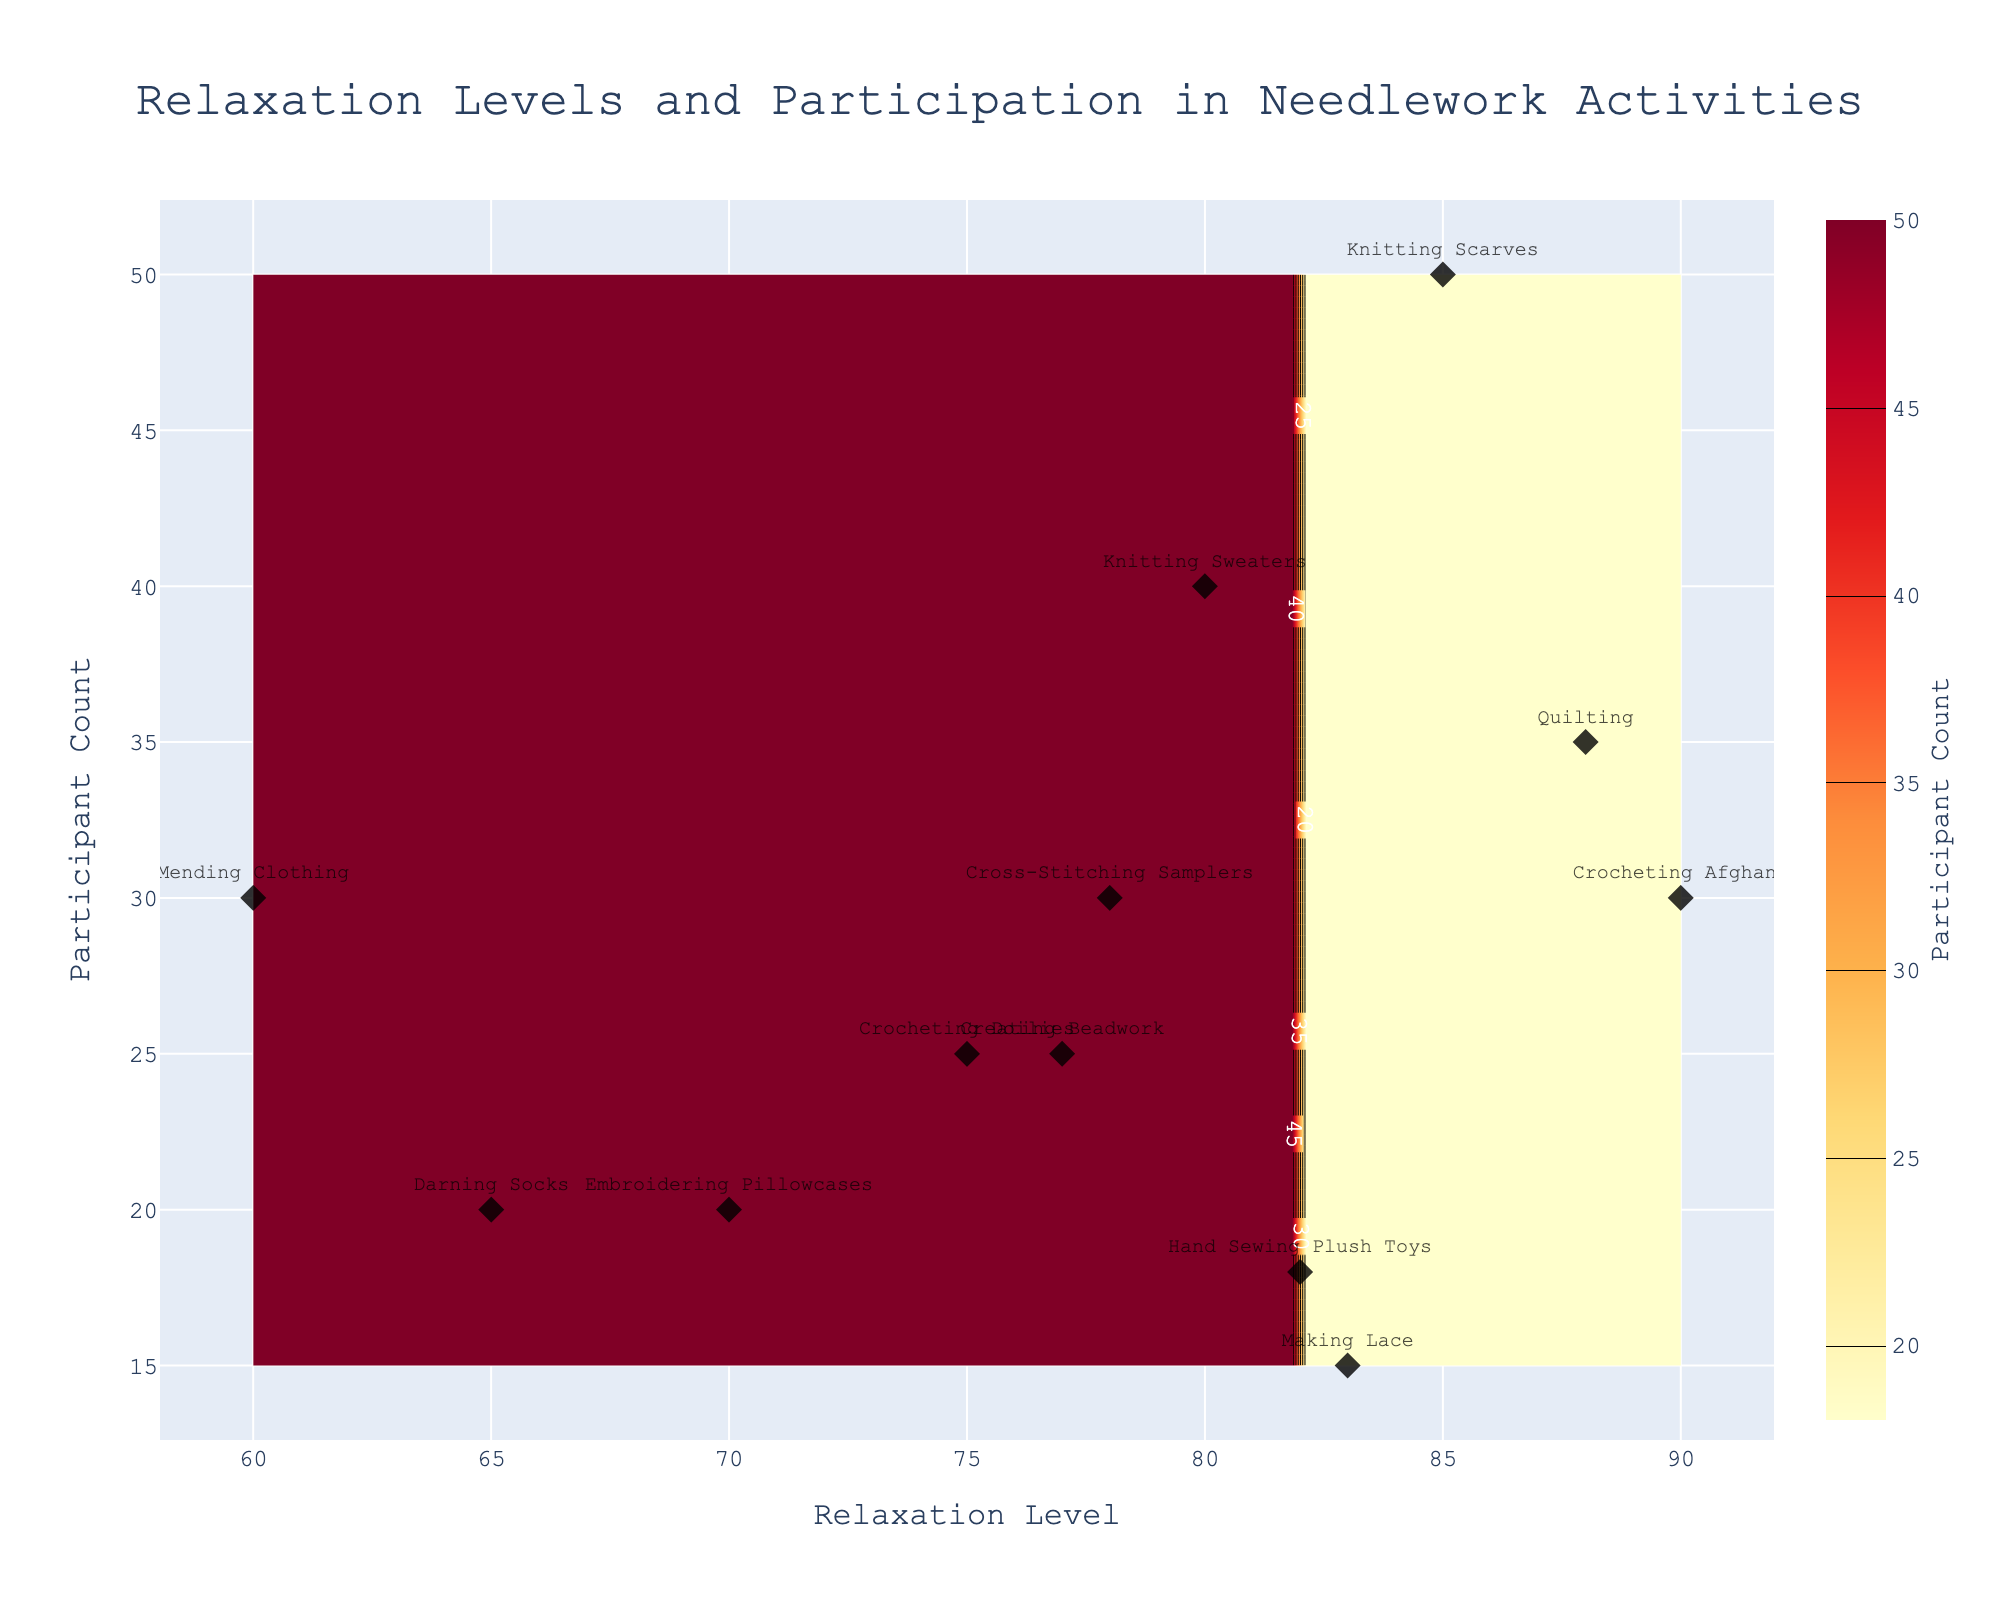What's the title of the figure? The title is located at the top-center of the figure and is in bold text. The title usually provides an insight into what the figure is about.
Answer: Relaxation Levels and Participation in Needlework Activities What is the range of Relaxation Levels on the x-axis? Look at the x-axis at the bottom of the figure to determine its range by noting the minimum and maximum tick marks.
Answer: 60 to 90 Which activity has the highest relaxation level? Locate the scatter plot data points and identify the activity label with the highest position on the x-axis.
Answer: Crocheting Afghans What is the participant count for Knitting Scarves? Find the data point labeled "Knitting Scarves" and refer to its position on the y-axis to get the number of participants.
Answer: 50 What activity has the lowest relaxation level? Look for the point with the lowest x-axis value, then read the corresponding label.
Answer: Embroidering Pillowcases Compare the relaxation levels for Knitting Sweaters and Hand Sewing Plush Toys. Which one is higher? Identify both points on the plot and compare their x-axis positions.
Answer: Hand Sewing Plush Toys Which activities have a participant count between 20 and 30? Check for scatter plot data points within the y-axis range of 20 to 30, then list their labels.
Answer: Crocheting Afghans, Crocheting Doilies, Emroidering Pillowcases, Darning Socks, Creating Beadwork How many activities have a relaxation level of 75 or above? Count the number of data points on or to the right of the x-axis value 75.
Answer: 9 What is the contour plot indicating in terms of participant count? Interpret the color gradient and contour lines to understand what high and low participant counts look like. The warmer colors indicate higher participant counts while cooler colors show fewer participants.
Answer: Participant count distribution Describe the relationship between relaxation levels and participant count for Mending Clothing. Find the scatter plot point for "Mending Clothing" and describe its x and y positions indicating a lower relaxation level and a modest participant count.
Answer: Lower relaxation, moderate participation 